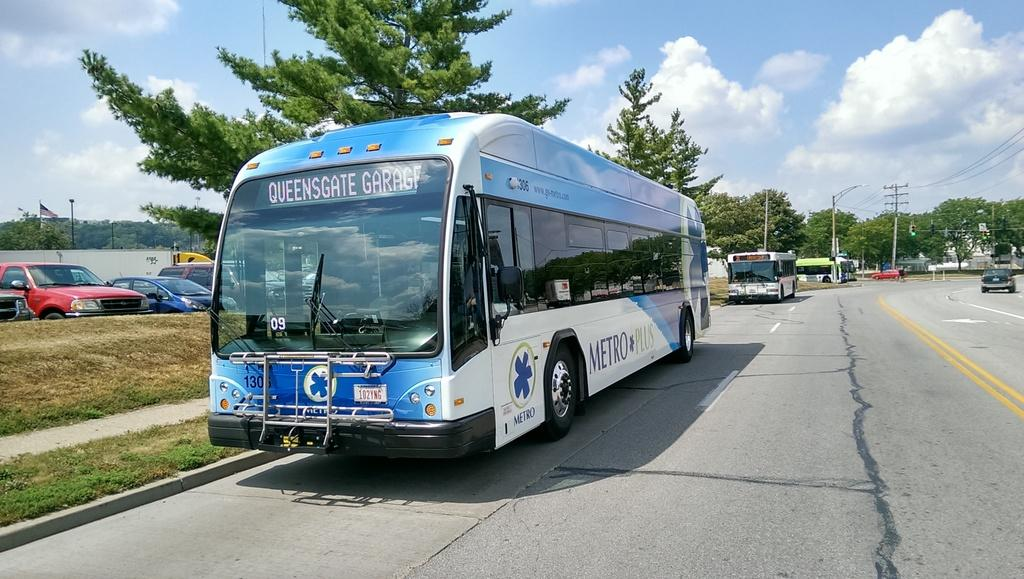<image>
Create a compact narrative representing the image presented. A bus running the Queensgate Garage route is on the road. 